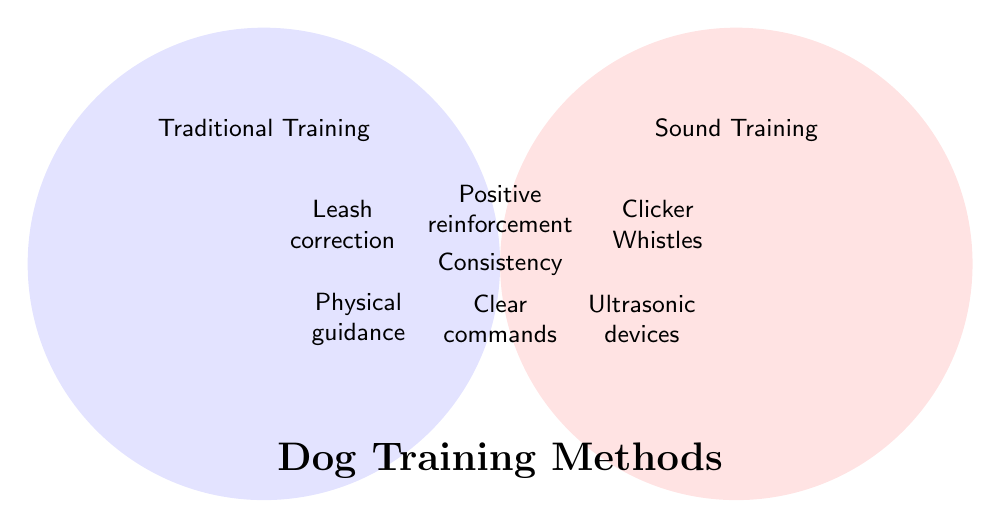What is the title of the figure? The title of the figure is located at the bottom and reads "Dog Training Methods".
Answer: Dog Training Methods What elements are included in the "Both" section of the Venn Diagram? The "Both" section lists the training methods that are common to both Sound Training and Traditional Training. These methods are Positive reinforcement, Consistency, and Clear commands.
Answer: Positive reinforcement, Consistency, Clear commands Which training method is shared by both Sound Training and Traditional Training and emphasized for having a consistent application? Within the "Both" section of the Venn Diagram, Consistency is highlighted as a shared method.
Answer: Consistency Which side of the Venn Diagram contains Clicker training? Clicker training is listed under the Sound Training section, which is on the right side of the Venn Diagram.
Answer: Sound Training List two methods exclusive to Traditional Training as shown in the Venn Diagram. The Traditional Training section, which is on the left side, includes Leash correction and Physical guidance as exclusive methods.
Answer: Leash correction, Physical guidance Which training method uses Whistles? The Sound Training section, which contains training methods like Clicker and Whistles, lists Whistles under Sound Training.
Answer: Sound Training Name a method that is exclusively used in Sound Training but not in Traditional Training. The Sound Training section lists methods such as Clicker, Whistles, Ultrasonic devices, and Electronic collars that are unique to Sound Training. For example, Clicker is exclusively used in Sound Training.
Answer: Clicker How many unique methods are identified in the Traditional Training section of the Venn Diagram? The Traditional Training section lists three unique methods: Leash correction, Physical guidance, and Verbal reprimands.
Answer: 3 Identify an element that uses positive stimuli in the training process from the Sound Training section. In the Sound Training section, one method that uses positive stimuli is Clicker training.
Answer: Clicker Compare the number of exclusive methods in Sound Training and Traditional Training. Which has more? Sound Training lists four exclusive methods (Clicker, Whistles, Ultrasonic devices, Electronic collars) while Traditional Training lists three (Leash correction, Physical guidance, Verbal reprimands). Thus, Sound Training has more exclusive methods.
Answer: Sound Training 